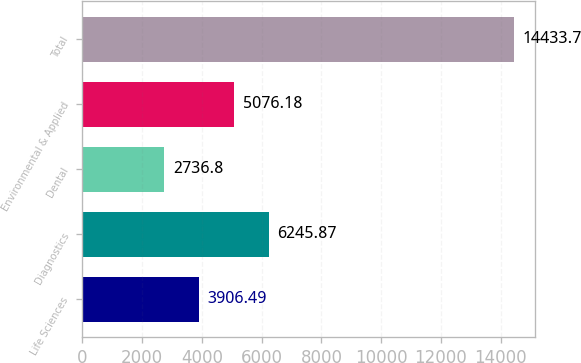Convert chart to OTSL. <chart><loc_0><loc_0><loc_500><loc_500><bar_chart><fcel>Life Sciences<fcel>Diagnostics<fcel>Dental<fcel>Environmental & Applied<fcel>Total<nl><fcel>3906.49<fcel>6245.87<fcel>2736.8<fcel>5076.18<fcel>14433.7<nl></chart> 